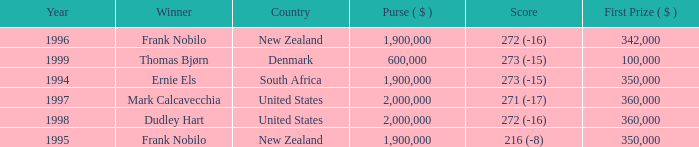What was the total purse in the years after 1996 with a score of 272 (-16) when frank nobilo won? None. Can you give me this table as a dict? {'header': ['Year', 'Winner', 'Country', 'Purse ( $ )', 'Score', 'First Prize ( $ )'], 'rows': [['1996', 'Frank Nobilo', 'New Zealand', '1,900,000', '272 (-16)', '342,000'], ['1999', 'Thomas Bjørn', 'Denmark', '600,000', '273 (-15)', '100,000'], ['1994', 'Ernie Els', 'South Africa', '1,900,000', '273 (-15)', '350,000'], ['1997', 'Mark Calcavecchia', 'United States', '2,000,000', '271 (-17)', '360,000'], ['1998', 'Dudley Hart', 'United States', '2,000,000', '272 (-16)', '360,000'], ['1995', 'Frank Nobilo', 'New Zealand', '1,900,000', '216 (-8)', '350,000']]} 